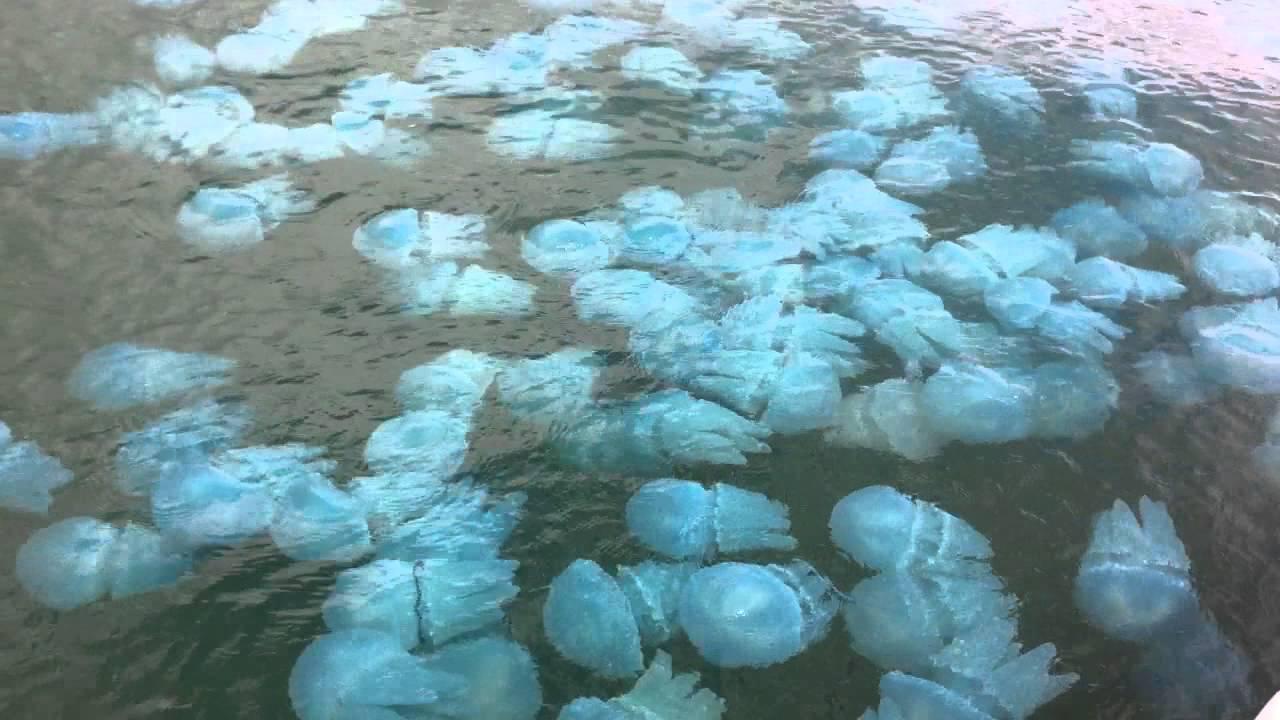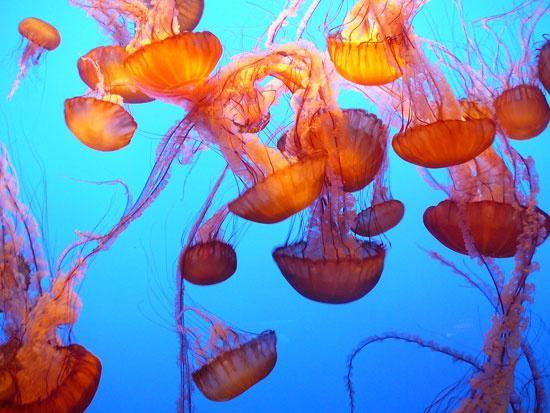The first image is the image on the left, the second image is the image on the right. Evaluate the accuracy of this statement regarding the images: "At least one image shows jellyfish of different colors.". Is it true? Answer yes or no. No. 